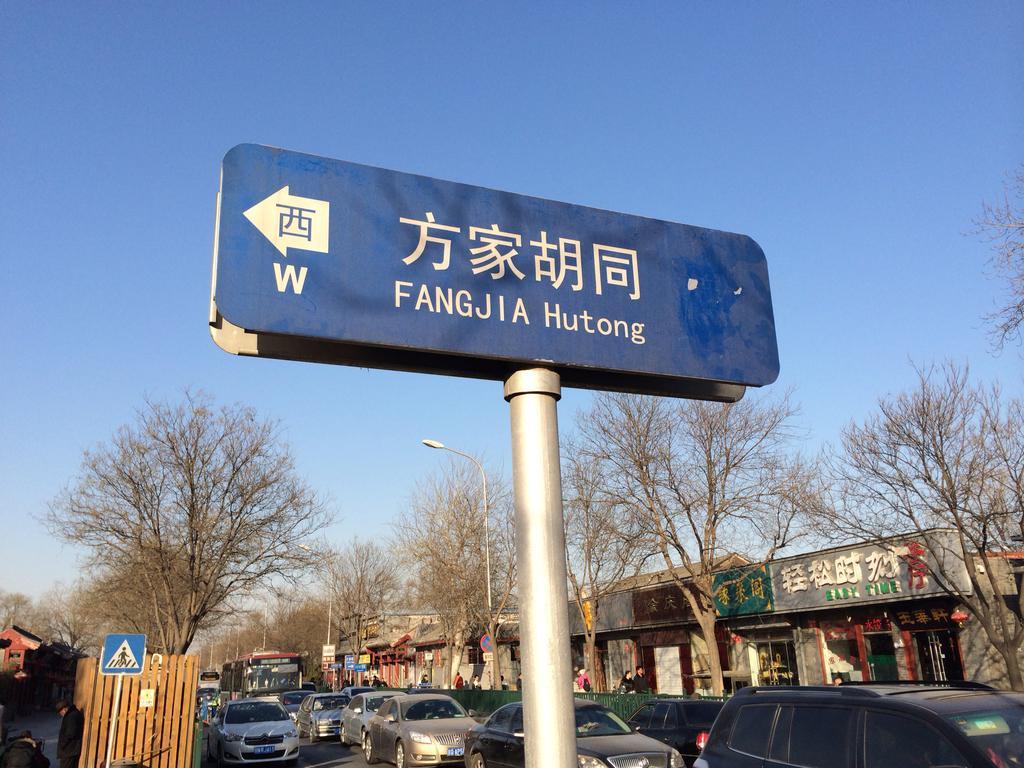Describe this image in one or two sentences. We can see boards on poles,fence and vehicles on the road. In the background we can see buildings,trees,lights on poles,boards and sky in blue color. 